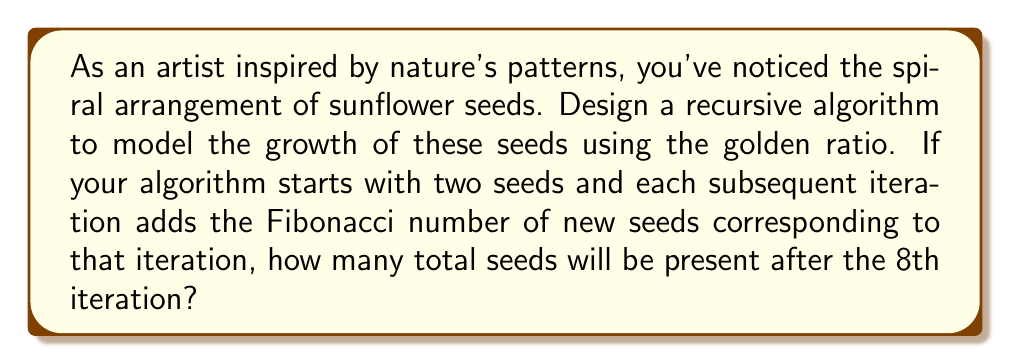Teach me how to tackle this problem. Let's approach this step-by-step:

1) First, recall that the Fibonacci sequence is closely related to the golden ratio. The sequence starts with 0 and 1, and each subsequent number is the sum of the two preceding ones.

2) Let's define our recursive algorithm:
   - Start with 2 seeds
   - For each iteration $n$ (where $n \geq 3$), add $F_{n}$ new seeds, where $F_{n}$ is the $n$-th Fibonacci number

3) Let's calculate the number of seeds for each iteration:

   Iteration 1: 2 seeds (given)
   Iteration 2: 2 seeds (given)
   Iteration 3: 2 + $F_3$ = 2 + 2 = 4 seeds
   Iteration 4: 4 + $F_4$ = 4 + 3 = 7 seeds
   Iteration 5: 7 + $F_5$ = 7 + 5 = 12 seeds
   Iteration 6: 12 + $F_6$ = 12 + 8 = 20 seeds
   Iteration 7: 20 + $F_7$ = 20 + 13 = 33 seeds
   Iteration 8: 33 + $F_8$ = 33 + 21 = 54 seeds

4) The Fibonacci sequence up to $F_8$ is:
   $$F_1 = 1, F_2 = 1, F_3 = 2, F_4 = 3, F_5 = 5, F_6 = 8, F_7 = 13, F_8 = 21$$

5) We can express this as a sum:
   $$\text{Total seeds} = 2 + \sum_{i=3}^{8} F_i = 2 + (2 + 3 + 5 + 8 + 13 + 21) = 54$$

This recursive algorithm models the golden ratio because the ratio of consecutive Fibonacci numbers converges to the golden ratio as the sequence progresses.
Answer: 54 seeds 